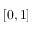Convert formula to latex. <formula><loc_0><loc_0><loc_500><loc_500>[ 0 , 1 ]</formula> 